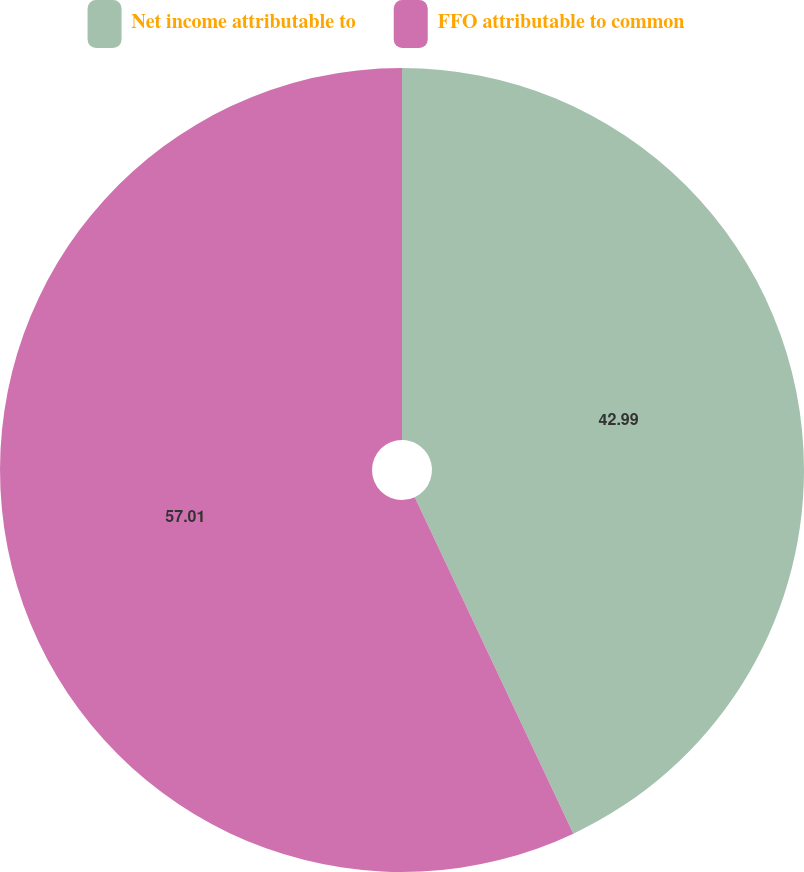Convert chart to OTSL. <chart><loc_0><loc_0><loc_500><loc_500><pie_chart><fcel>Net income attributable to<fcel>FFO attributable to common<nl><fcel>42.99%<fcel>57.01%<nl></chart> 